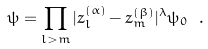Convert formula to latex. <formula><loc_0><loc_0><loc_500><loc_500>\psi = \prod _ { l > m } | z _ { l } ^ { ( \alpha ) } - z _ { m } ^ { ( \beta ) } | ^ { \lambda } \psi _ { 0 } \ .</formula> 